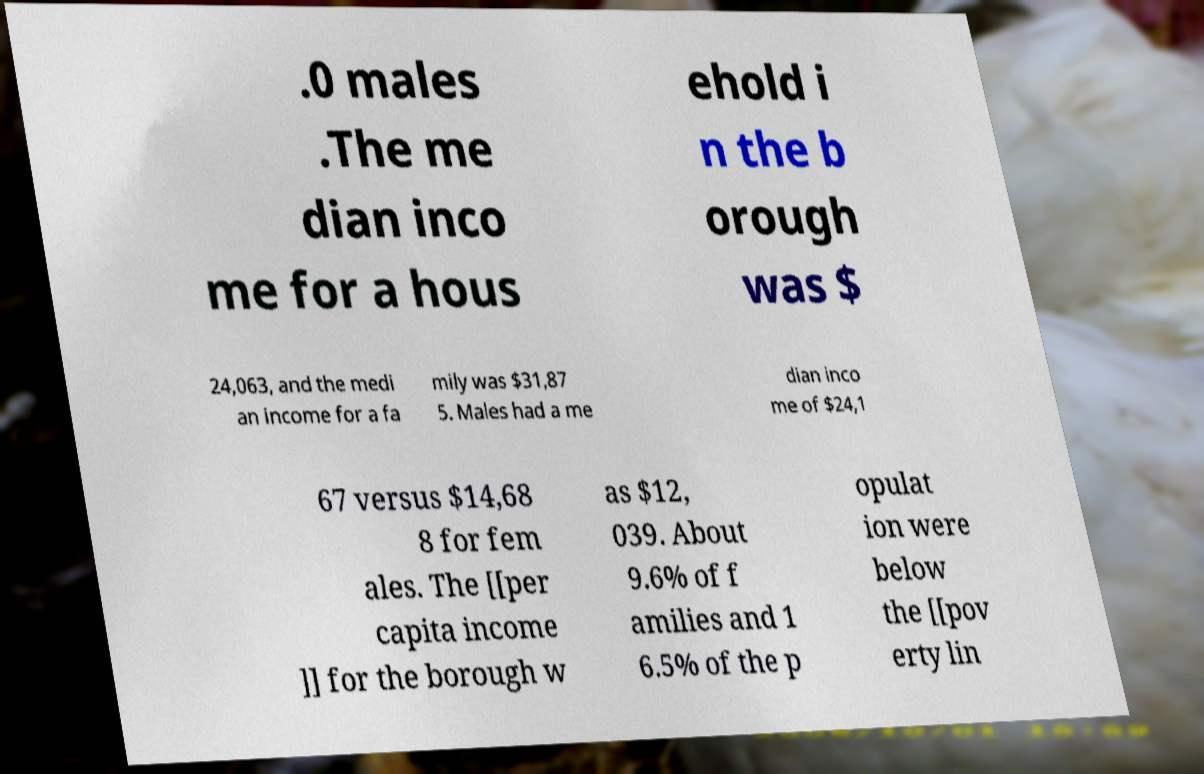For documentation purposes, I need the text within this image transcribed. Could you provide that? .0 males .The me dian inco me for a hous ehold i n the b orough was $ 24,063, and the medi an income for a fa mily was $31,87 5. Males had a me dian inco me of $24,1 67 versus $14,68 8 for fem ales. The [[per capita income ]] for the borough w as $12, 039. About 9.6% of f amilies and 1 6.5% of the p opulat ion were below the [[pov erty lin 